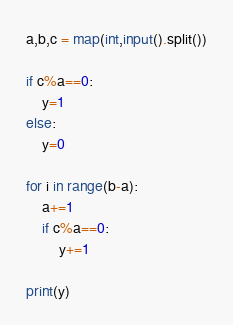<code> <loc_0><loc_0><loc_500><loc_500><_Python_>a,b,c = map(int,input().split())

if c%a==0:
    y=1
else:
    y=0

for i in range(b-a):
    a+=1
    if c%a==0:
        y+=1

print(y)

</code> 